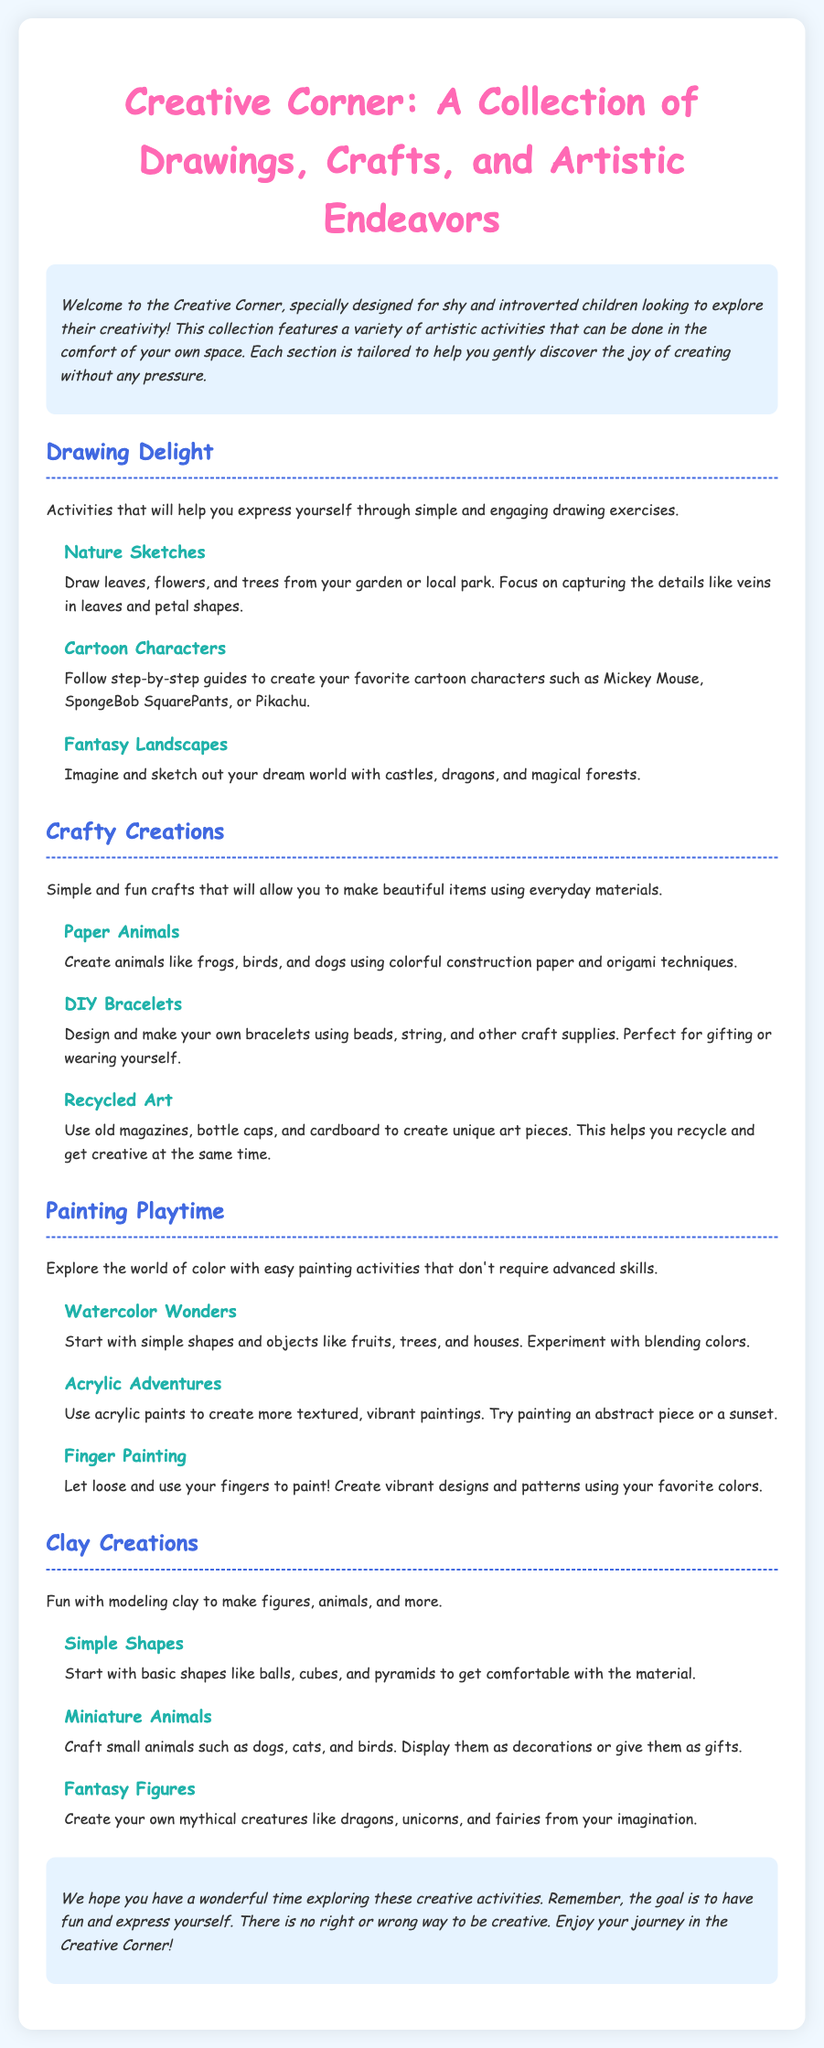What is the title of the document? The title is stated prominently at the top of the document.
Answer: Creative Corner: A Collection of Drawings, Crafts, and Artistic Endeavors Who is the intended audience for this collection? The introduction indicates that this collection is designed specifically for a certain type of children.
Answer: Shy and introverted children How many sections are in the document? The document clearly divides its content into multiple distinct sections.
Answer: Four What is one activity suggested under "Drawing Delight"? The section on drawing provides various engaging activities for creativity.
Answer: Nature Sketches What materials are suggested for creating "Paper Animals"? The subsection identifies specific supplies needed for this craft.
Answer: Colorful construction paper and origami techniques Which painting method allows for using your fingers? One subsection specifically mentions using fingers for a type of painting.
Answer: Finger Painting What kind of figures can be created in the "Clay Creations" section? The document describes specific items that can be made using modeling clay.
Answer: Animals What is the overall goal mentioned in the conclusion? The conclusion summarizes the purpose of the activities shared throughout the document.
Answer: To have fun and express yourself 